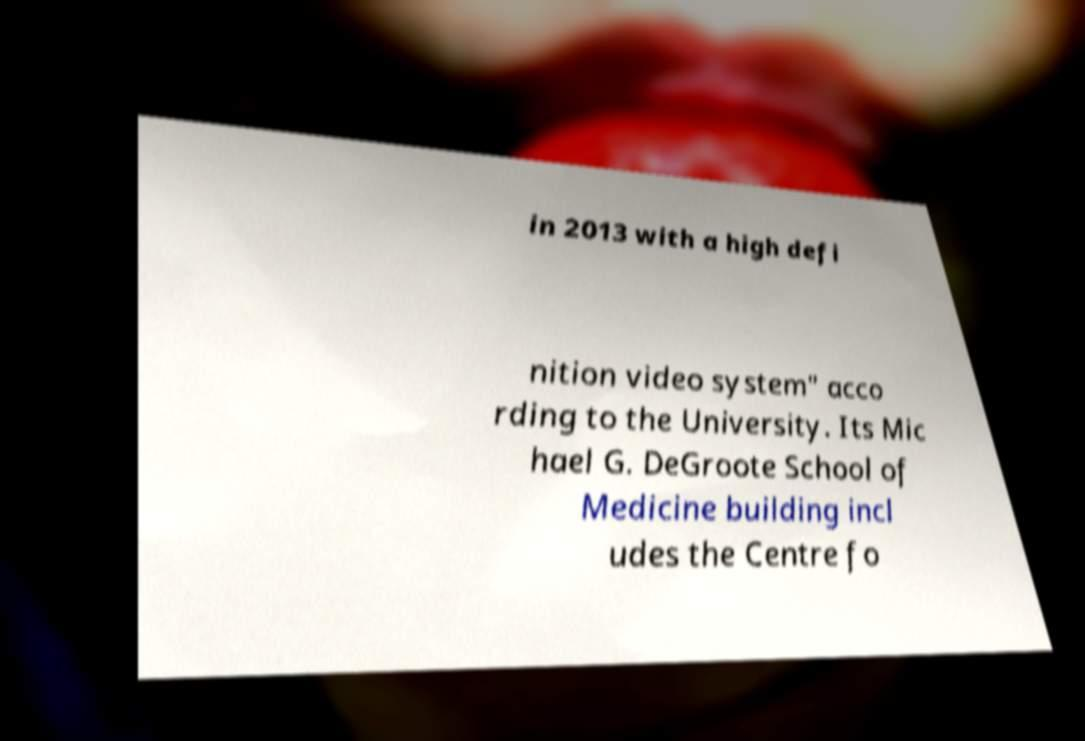There's text embedded in this image that I need extracted. Can you transcribe it verbatim? in 2013 with a high defi nition video system" acco rding to the University. Its Mic hael G. DeGroote School of Medicine building incl udes the Centre fo 